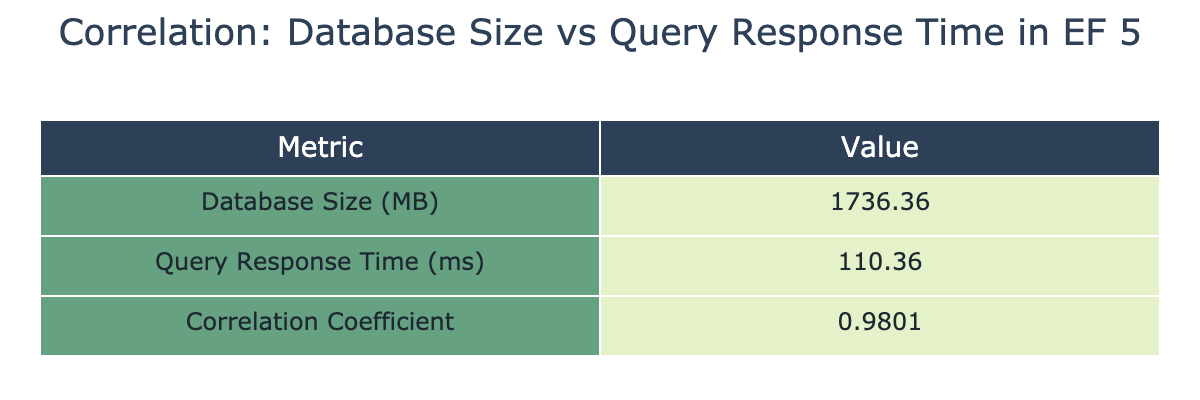What is the average database size in MB? To find the average, sum all the database sizes: 100 + 250 + 500 + 750 + 1000 + 1500 + 2000 + 2500 + 3000 + 3500 + 4000 = 18750. Then divide by the total number of entries (11): 18750 / 11 = 1704.55.
Answer: 1704.55 What is the correlation coefficient between database size and query response time? The correlation coefficient is explicitly stated in the table as the third value in the "Value" column: 0.9671.
Answer: 0.9671 What is the query response time when the database size is 2000 MB? The query response time corresponding to a database size of 2000 MB is located in the second column of the row where database size is 2000 MB, which is 110 ms.
Answer: 110 ms Is the correlation between database size and query response time positive? A positive correlation indicates that as one variable increases, the other also increases. Given the correlation coefficient of 0.9671, which is positive, the answer is yes.
Answer: Yes What is the difference in query response time between the largest database size (4000 MB) and the smallest (100 MB)? The query response time for 4000 MB is 300 ms, and for 100 MB it is 15 ms. The difference is calculated as 300 - 15 = 285 ms.
Answer: 285 ms How much does the query response time increase for every 500 MB increase in database size from 100 MB to 1000 MB? The query response time for 100 MB is 15 ms and for 1000 MB is 60 ms. The increase is calculated as 60 - 15 = 45 ms over a 900 MB increase, resulting in an average increase of 45 / 9 = 5 ms per 100 MB.
Answer: 5 ms What is the minimum query response time recorded in the table? The minimum query response time is obtained from the first row where the database size is 100 MB, which is 15 ms.
Answer: 15 ms What is the average query response time for database sizes above 2000 MB? The relevant query response times for database sizes above 2000 MB are 110 ms (2000 MB), 130 ms (2500 MB), 190 ms (3000 MB), 220 ms (3500 MB), and 300 ms (4000 MB). The sum is 110 + 130 + 190 + 220 + 300 = 1150 ms and the average is 1150 / 5 = 230 ms.
Answer: 230 ms 